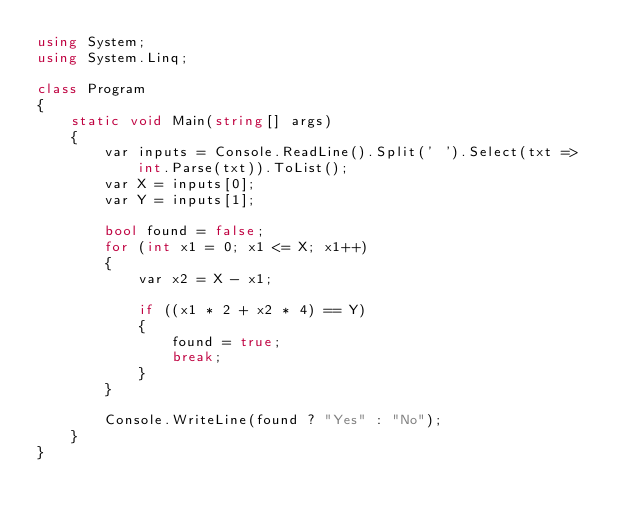Convert code to text. <code><loc_0><loc_0><loc_500><loc_500><_C#_>using System;
using System.Linq;

class Program
{
    static void Main(string[] args)
    {
        var inputs = Console.ReadLine().Split(' ').Select(txt => int.Parse(txt)).ToList();
        var X = inputs[0];
        var Y = inputs[1];

        bool found = false;
        for (int x1 = 0; x1 <= X; x1++)
        {
            var x2 = X - x1;

            if ((x1 * 2 + x2 * 4) == Y)
            {
                found = true;
                break;
            }
        }

        Console.WriteLine(found ? "Yes" : "No");
    }
}</code> 